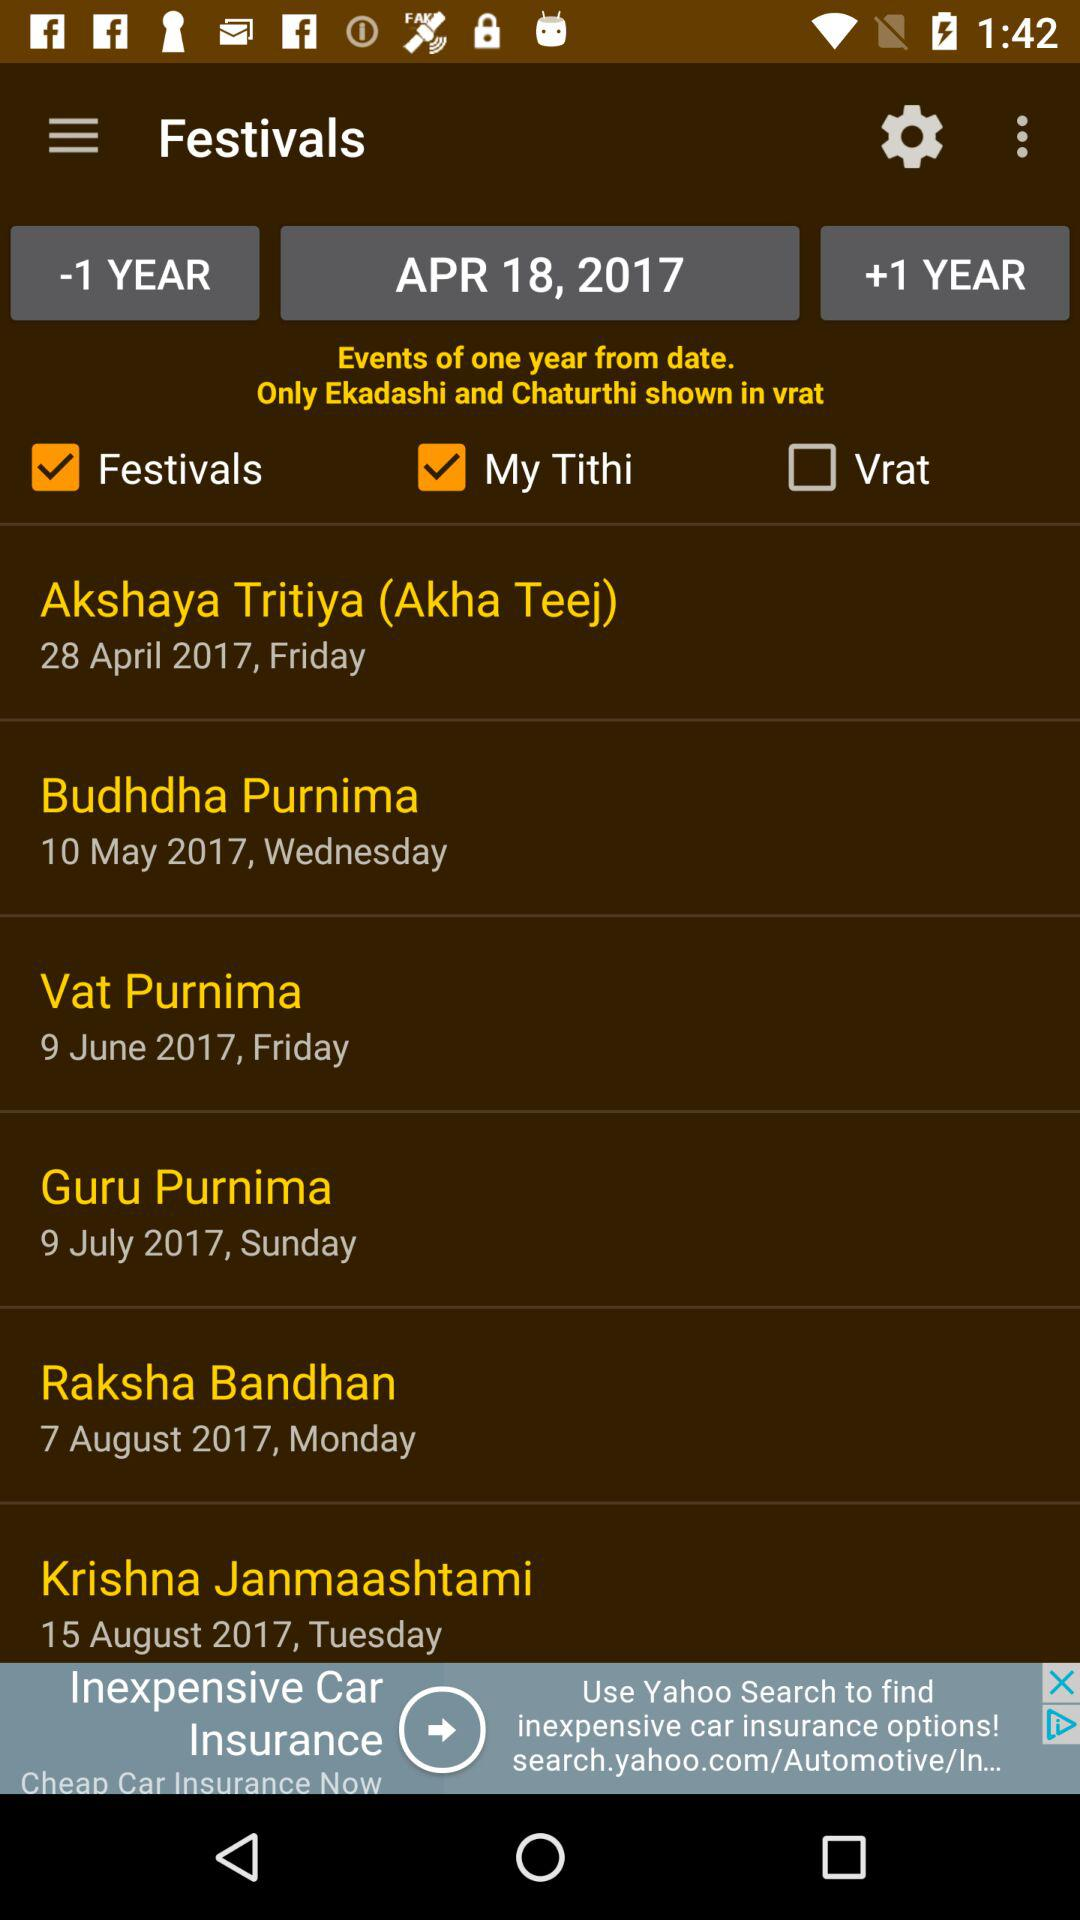What is the day on "Budhdha Purnima"? The day is Wednesday. 